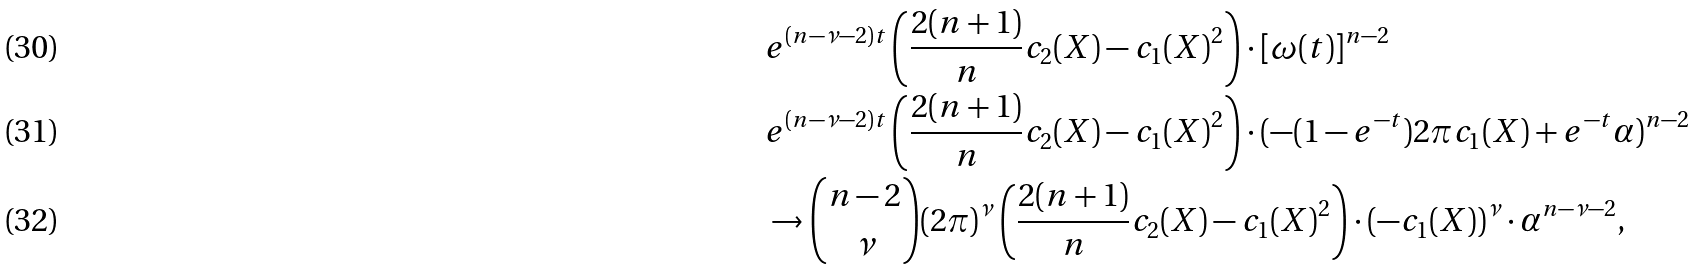Convert formula to latex. <formula><loc_0><loc_0><loc_500><loc_500>& e ^ { ( n - \nu - 2 ) t } \left ( \frac { 2 ( n + 1 ) } { n } c _ { 2 } ( X ) - c _ { 1 } ( X ) ^ { 2 } \right ) \cdot [ \omega ( t ) ] ^ { n - 2 } \\ & e ^ { ( n - \nu - 2 ) t } \left ( \frac { 2 ( n + 1 ) } { n } c _ { 2 } ( X ) - c _ { 1 } ( X ) ^ { 2 } \right ) \cdot ( - ( 1 - e ^ { - t } ) 2 \pi c _ { 1 } ( X ) + e ^ { - t } \alpha ) ^ { n - 2 } \\ & \to \binom { n - 2 } { \nu } ( 2 \pi ) ^ { \nu } \left ( \frac { 2 ( n + 1 ) } { n } c _ { 2 } ( X ) - c _ { 1 } ( X ) ^ { 2 } \right ) \cdot ( - c _ { 1 } ( X ) ) ^ { \nu } \cdot \alpha ^ { n - \nu - 2 } ,</formula> 